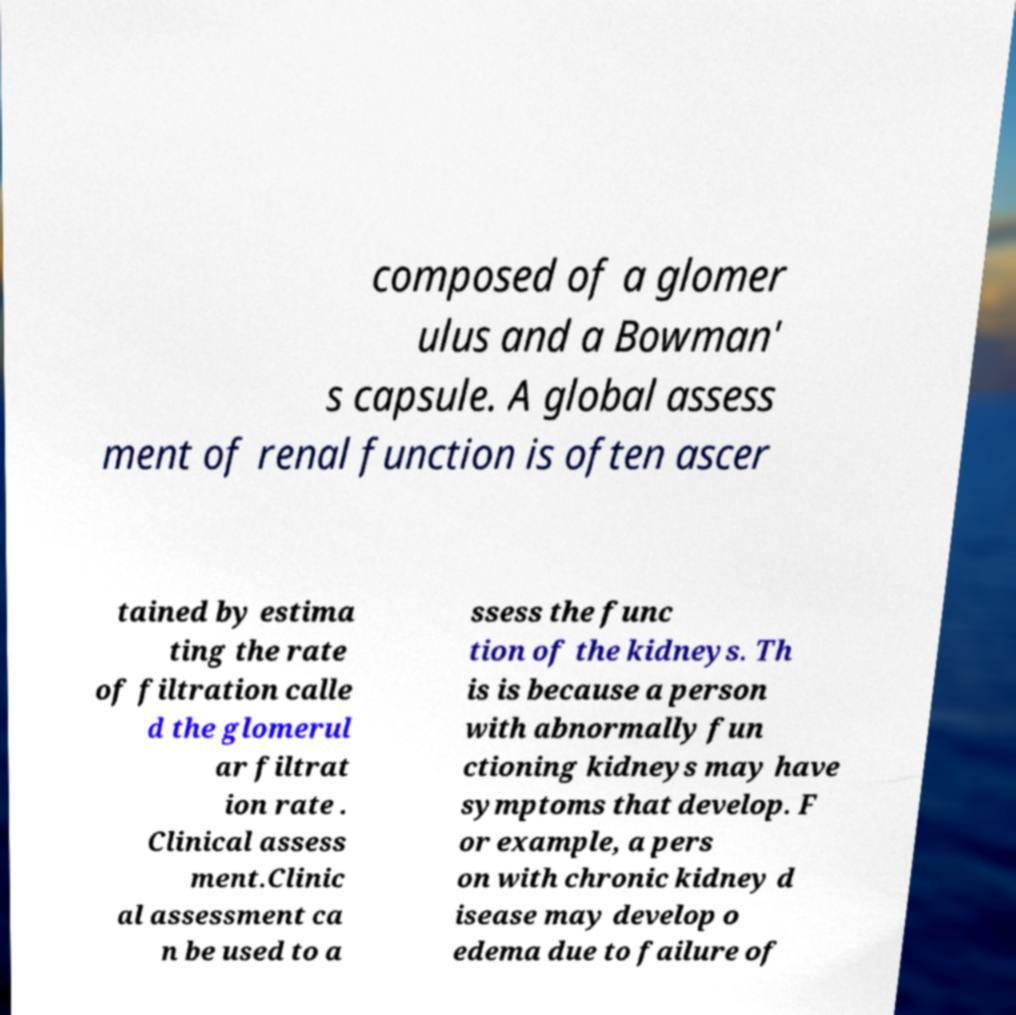Please identify and transcribe the text found in this image. composed of a glomer ulus and a Bowman' s capsule. A global assess ment of renal function is often ascer tained by estima ting the rate of filtration calle d the glomerul ar filtrat ion rate . Clinical assess ment.Clinic al assessment ca n be used to a ssess the func tion of the kidneys. Th is is because a person with abnormally fun ctioning kidneys may have symptoms that develop. F or example, a pers on with chronic kidney d isease may develop o edema due to failure of 